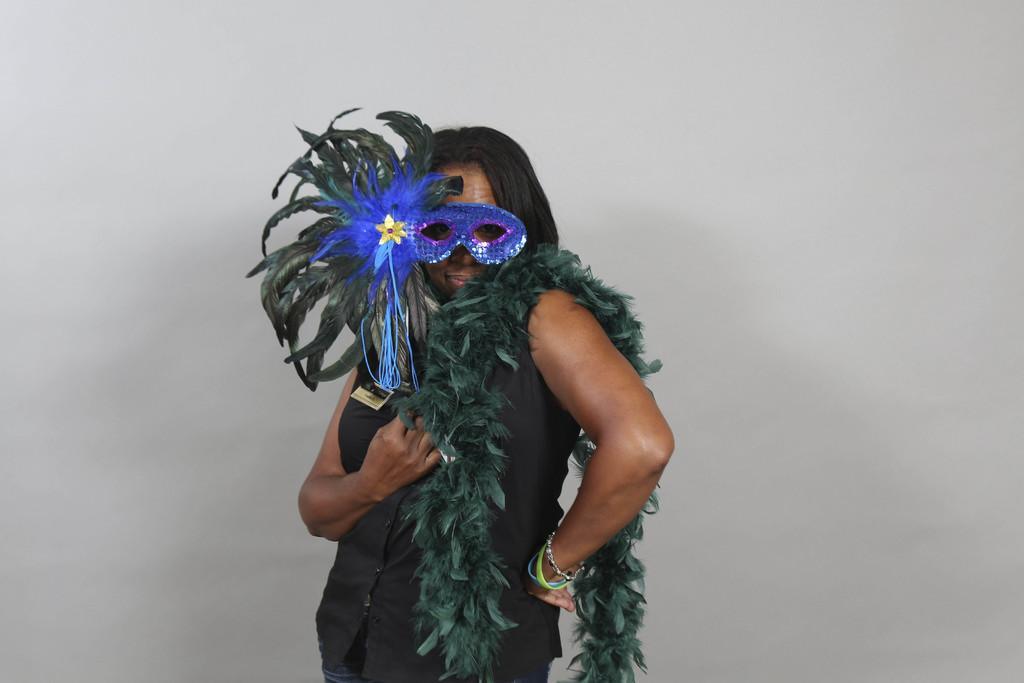Can you describe this image briefly? In this image there is a person holding a costume and wearing some decorative item, behind her there is a wall. 